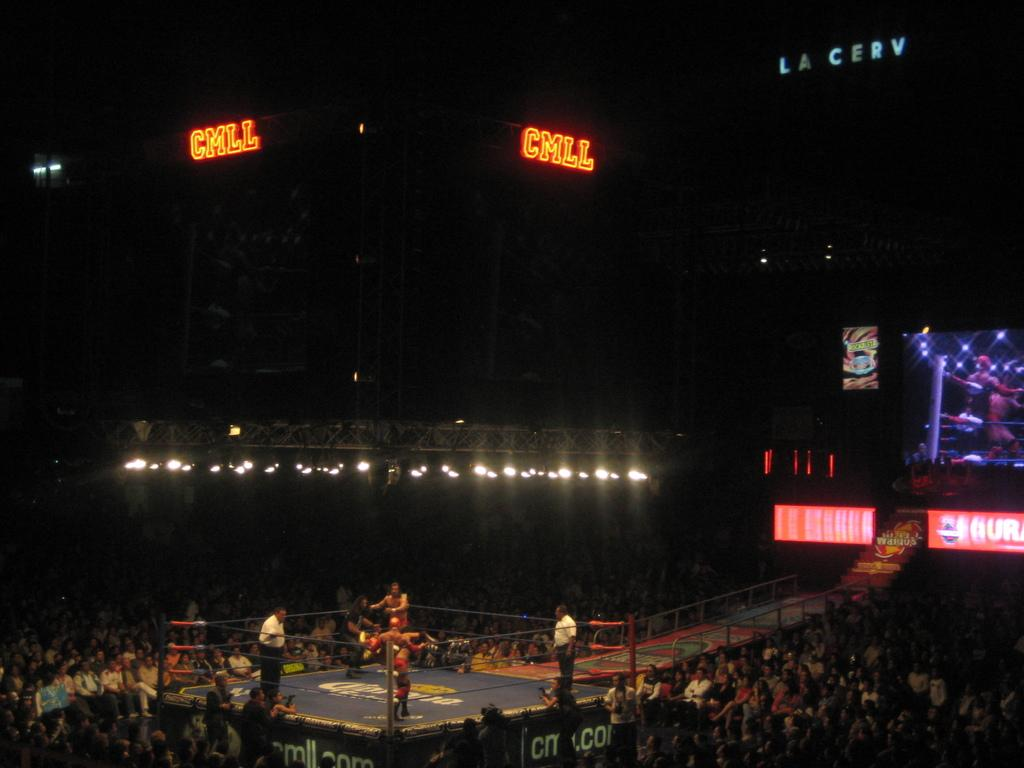<image>
Give a short and clear explanation of the subsequent image. A boxing match is filled with a crowd and the display panel above shows "CMLL". 